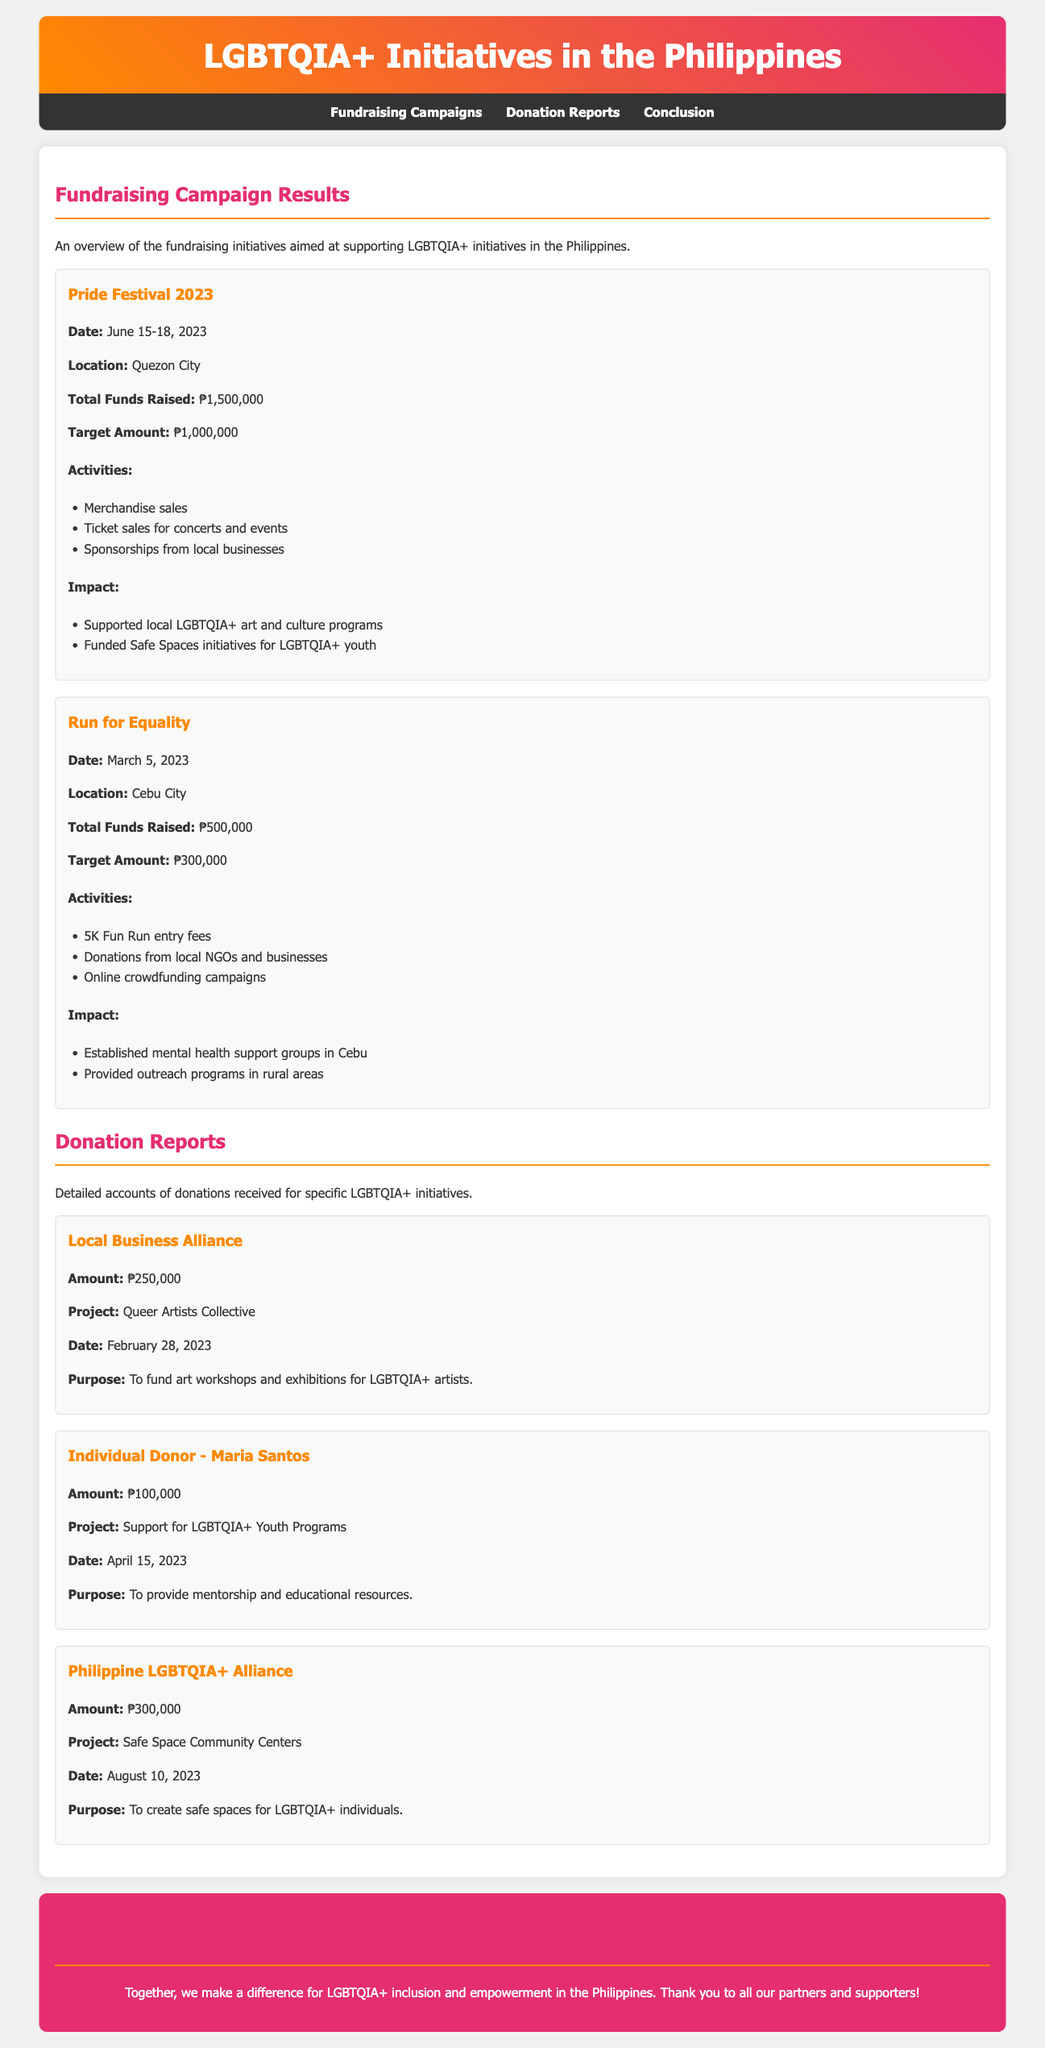What was the total amount raised during the Pride Festival 2023? The total amount raised during the Pride Festival 2023 is mentioned in the document under the fundraising campaign results.
Answer: ₱1,500,000 When did the Run for Equality fundraising event take place? The date for the Run for Equality event is specified in the document as part of the campaign details.
Answer: March 5, 2023 What was the target amount for the Run for Equality campaign? The target amount for the Run for Equality campaign is provided in the fundraising section of the document.
Answer: ₱300,000 Which project received a donation of ₱300,000? The specific project that received this amount is mentioned in the donation reports section.
Answer: Safe Space Community Centers What activities were included in the Pride Festival 2023? The document lists activities related to this fundraising event that contributed to the total funds raised.
Answer: Merchandise sales, Ticket sales for concerts and events, Sponsorships from local businesses What was the purpose of the donation by Maria Santos? The purpose of the donation is described in the details of the individual donor section in the document.
Answer: To provide mentorship and educational resources How much did the Local Business Alliance donate? The donation amount from the Local Business Alliance is provided in the donation reports section.
Answer: ₱250,000 What impact did the Pride Festival 2023 have? The document lists impacts related to the funds raised during this event, showing its significance.
Answer: Supported local LGBTQIA+ art and culture programs, Funded Safe Spaces initiatives for LGBTQIA+ youth Which city hosted the Pride Festival 2023? The document specifies the location of the Pride Festival, which is relevant to the fundraising context.
Answer: Quezon City 